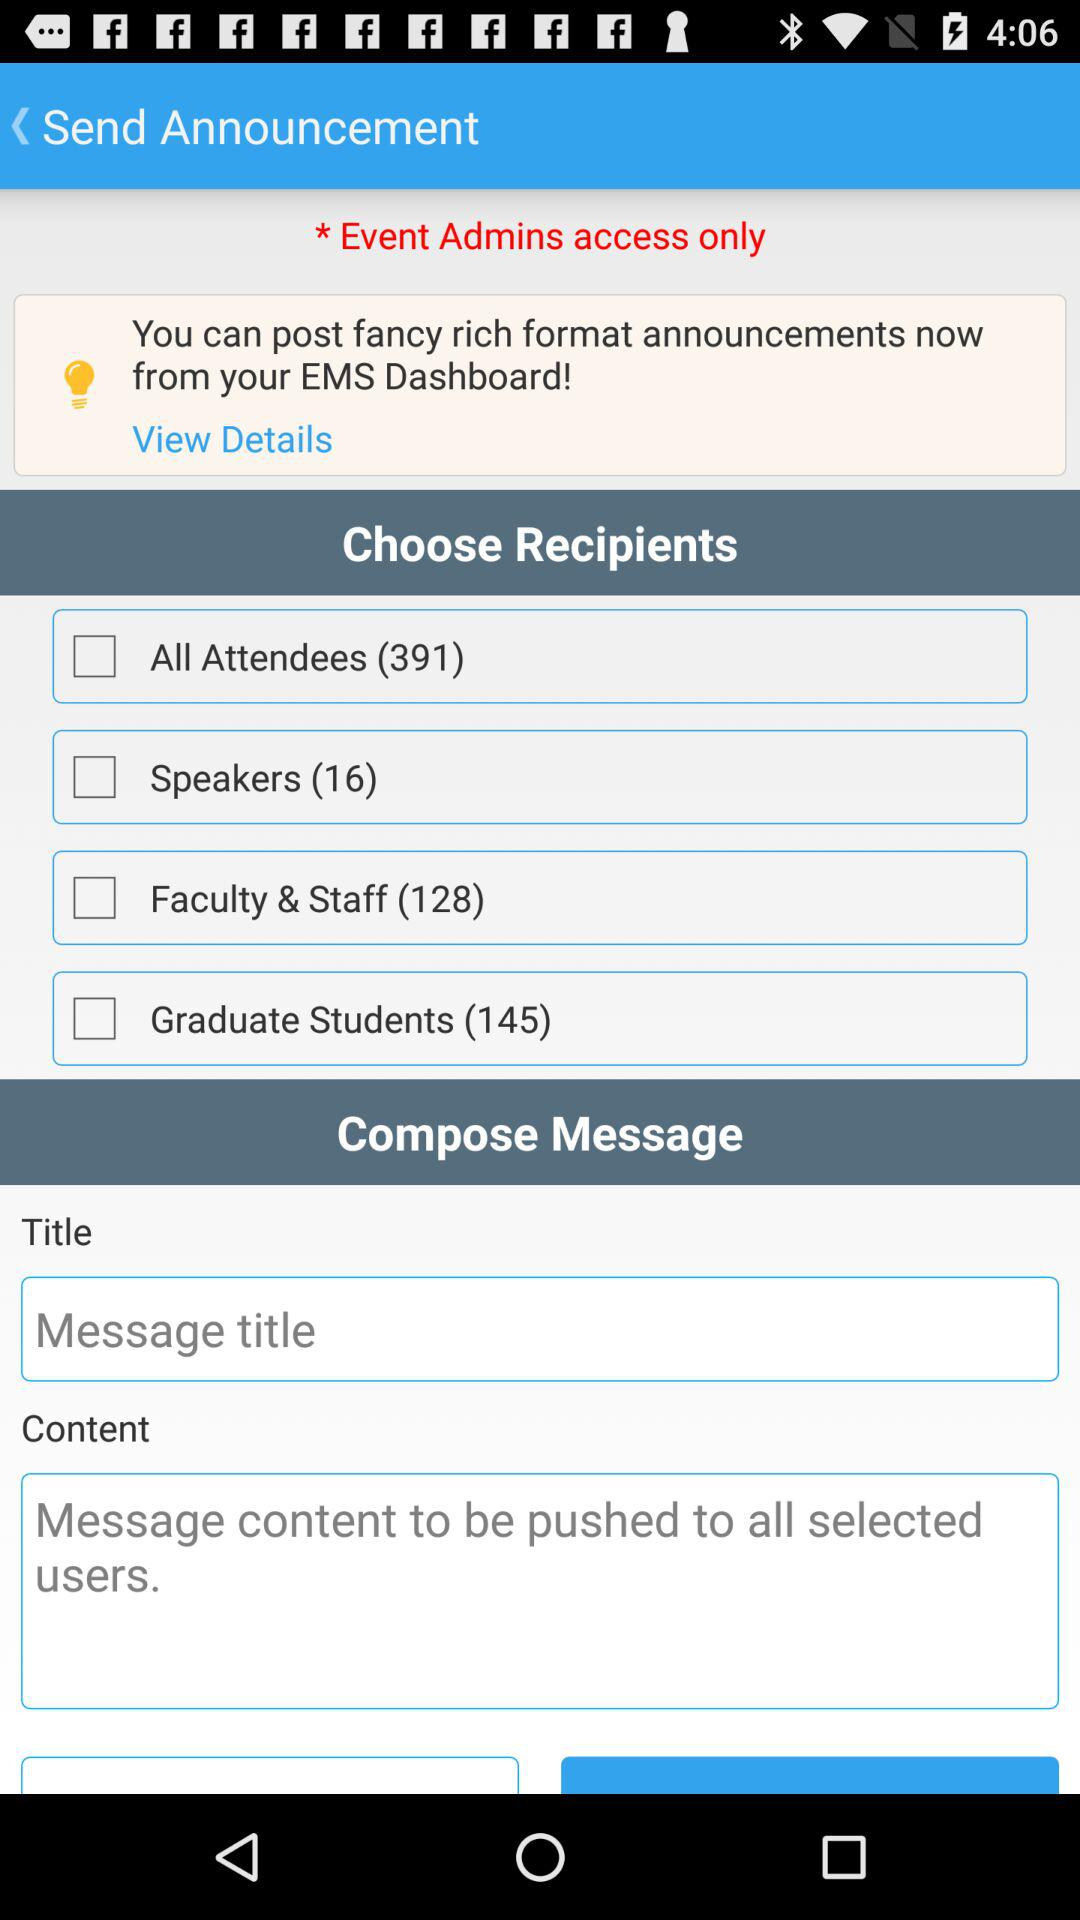How many people are there in "All Attendees"? There are 391 people. 